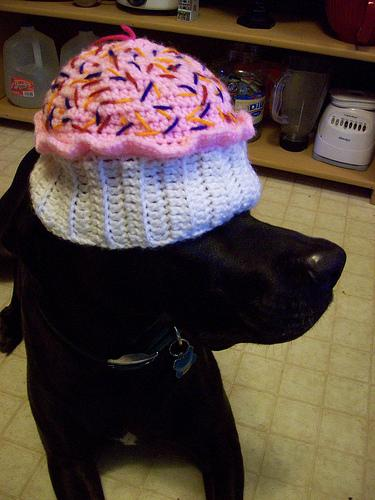What item is sitting on the top shelf in the image provided? A red container is sitting on the top shelf. Identify the main object in the image and provide a brief description. The main object is the black dog who is sitting on the floor and wearing a white, red, blue, and pink knitted hat that covers its eyes. Please identify the animal present in the image and the color of its collar. There is a black dog in the image, and it is wearing a blue collar. In the image, how many gallons of water are there and where can they be found? There are two gallons of water which are located on the bottom shelf of the wooden shelf behind the dog. What type of flooring is under the black dog in the image? The flooring under the black dog is a tiled tan floor. What object is covering the dog's eyes in the image? The bottom of the hat is covering the dog's eyes in the image. Provide a summary of the objects and their placement in the image. The image shows a black dog wearing a crocheted cupcake hat and a blue collar with a metal tag, sitting on a tile floor. Behind the dog, there is a wooden shelf with a white blender, gallons of water, and various other objects. Count the visible number of red yarns in the pink yarn on the dog's hat. There are four visible red yarns in the pink yarn on the dog's hat. What sentiment might this image evoke in a viewer? This image might evoke amusement and delight in a viewer, due to the dog's unique hat and relaxed pose. Describe the dog's hat in the image. The dog is wearing a white, red, blue, and pink knitted hat with stitched sprinkles resembling a cupcake. Find the blue crocheted hat on the dog's head. There is only a white and pink knitted hat on the dog's head, not a blue one. Where is the green metal tag on the dog's collar? There is a blue metal tag on the dog's collar, not a green one. Where is the brown spot of fur on the dog's chest? There is a white spot of fur on the dog's chest, not a brown one. Can you find the dog wearing a purple and green hat? The dog is wearing a white and pink knitted hat, not a purple and green one. Locate the small red object on the shelf. There is a small green object on the shelf, not a red one. Can you find the blue blender base on the bottom shelf? There is a white blender base on the bottom shelf, not a blue one. 